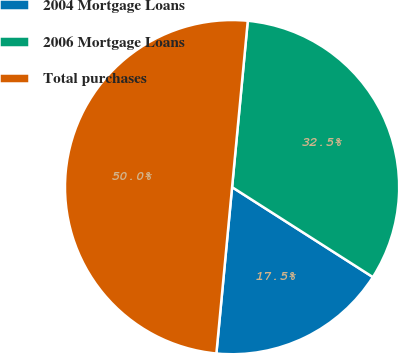Convert chart. <chart><loc_0><loc_0><loc_500><loc_500><pie_chart><fcel>2004 Mortgage Loans<fcel>2006 Mortgage Loans<fcel>Total purchases<nl><fcel>17.45%<fcel>32.55%<fcel>50.0%<nl></chart> 